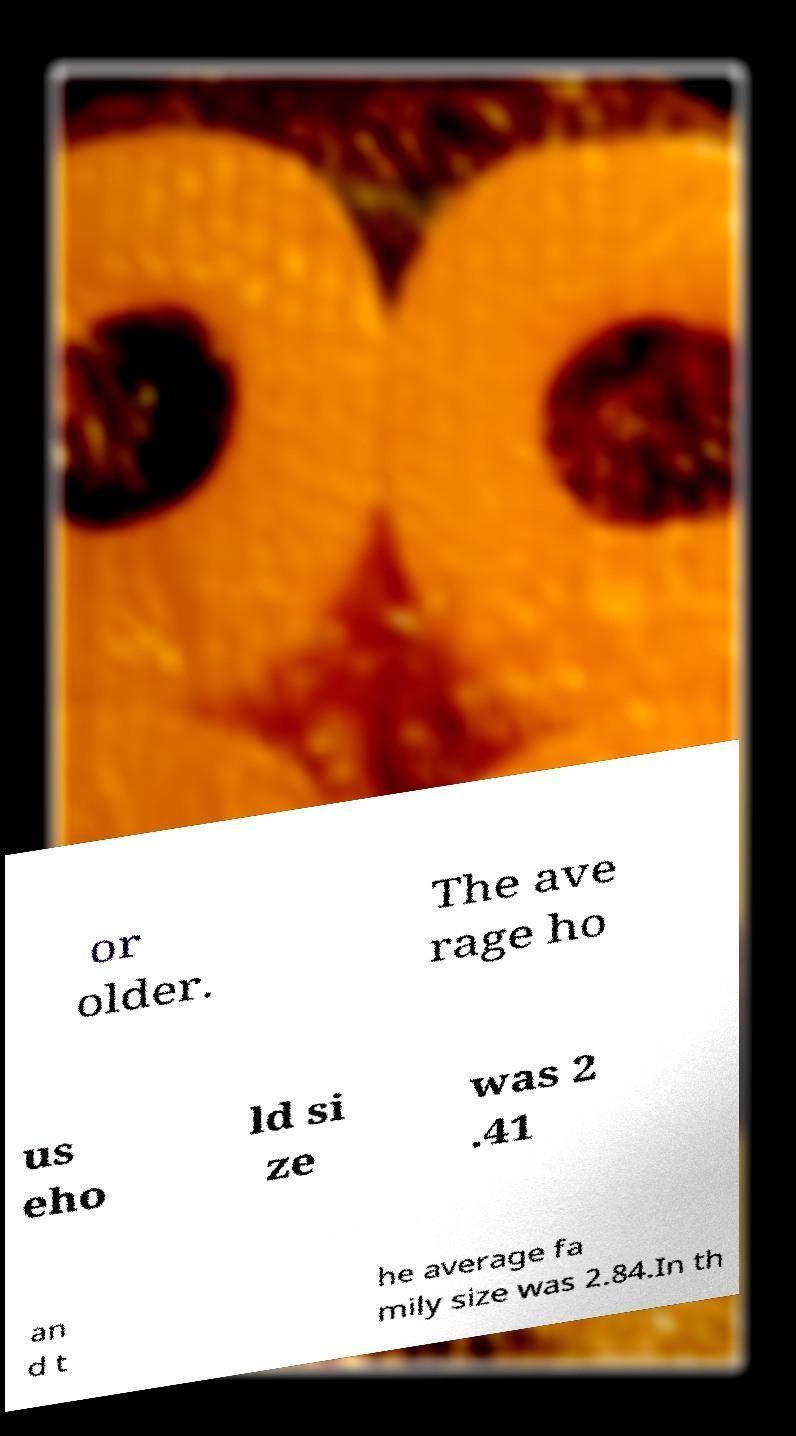Can you read and provide the text displayed in the image?This photo seems to have some interesting text. Can you extract and type it out for me? or older. The ave rage ho us eho ld si ze was 2 .41 an d t he average fa mily size was 2.84.In th 